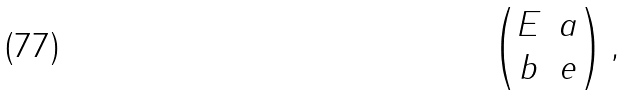Convert formula to latex. <formula><loc_0><loc_0><loc_500><loc_500>\begin{pmatrix} E & a \\ b & e \end{pmatrix} ,</formula> 